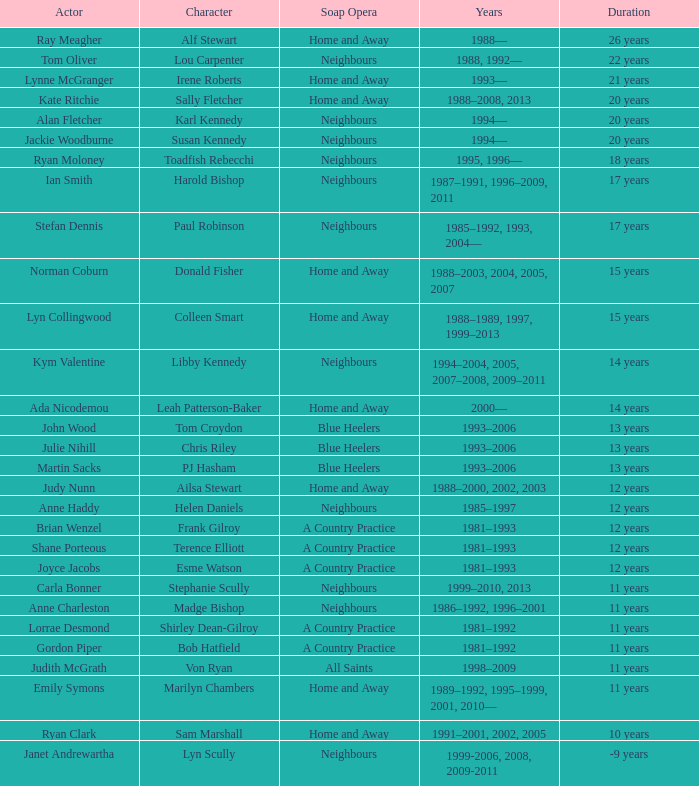Which years did Martin Sacks work on a soap opera? 1993–2006. Could you parse the entire table? {'header': ['Actor', 'Character', 'Soap Opera', 'Years', 'Duration'], 'rows': [['Ray Meagher', 'Alf Stewart', 'Home and Away', '1988—', '26 years'], ['Tom Oliver', 'Lou Carpenter', 'Neighbours', '1988, 1992—', '22 years'], ['Lynne McGranger', 'Irene Roberts', 'Home and Away', '1993—', '21 years'], ['Kate Ritchie', 'Sally Fletcher', 'Home and Away', '1988–2008, 2013', '20 years'], ['Alan Fletcher', 'Karl Kennedy', 'Neighbours', '1994—', '20 years'], ['Jackie Woodburne', 'Susan Kennedy', 'Neighbours', '1994—', '20 years'], ['Ryan Moloney', 'Toadfish Rebecchi', 'Neighbours', '1995, 1996—', '18 years'], ['Ian Smith', 'Harold Bishop', 'Neighbours', '1987–1991, 1996–2009, 2011', '17 years'], ['Stefan Dennis', 'Paul Robinson', 'Neighbours', '1985–1992, 1993, 2004—', '17 years'], ['Norman Coburn', 'Donald Fisher', 'Home and Away', '1988–2003, 2004, 2005, 2007', '15 years'], ['Lyn Collingwood', 'Colleen Smart', 'Home and Away', '1988–1989, 1997, 1999–2013', '15 years'], ['Kym Valentine', 'Libby Kennedy', 'Neighbours', '1994–2004, 2005, 2007–2008, 2009–2011', '14 years'], ['Ada Nicodemou', 'Leah Patterson-Baker', 'Home and Away', '2000—', '14 years'], ['John Wood', 'Tom Croydon', 'Blue Heelers', '1993–2006', '13 years'], ['Julie Nihill', 'Chris Riley', 'Blue Heelers', '1993–2006', '13 years'], ['Martin Sacks', 'PJ Hasham', 'Blue Heelers', '1993–2006', '13 years'], ['Judy Nunn', 'Ailsa Stewart', 'Home and Away', '1988–2000, 2002, 2003', '12 years'], ['Anne Haddy', 'Helen Daniels', 'Neighbours', '1985–1997', '12 years'], ['Brian Wenzel', 'Frank Gilroy', 'A Country Practice', '1981–1993', '12 years'], ['Shane Porteous', 'Terence Elliott', 'A Country Practice', '1981–1993', '12 years'], ['Joyce Jacobs', 'Esme Watson', 'A Country Practice', '1981–1993', '12 years'], ['Carla Bonner', 'Stephanie Scully', 'Neighbours', '1999–2010, 2013', '11 years'], ['Anne Charleston', 'Madge Bishop', 'Neighbours', '1986–1992, 1996–2001', '11 years'], ['Lorrae Desmond', 'Shirley Dean-Gilroy', 'A Country Practice', '1981–1992', '11 years'], ['Gordon Piper', 'Bob Hatfield', 'A Country Practice', '1981–1992', '11 years'], ['Judith McGrath', 'Von Ryan', 'All Saints', '1998–2009', '11 years'], ['Emily Symons', 'Marilyn Chambers', 'Home and Away', '1989–1992, 1995–1999, 2001, 2010—', '11 years'], ['Ryan Clark', 'Sam Marshall', 'Home and Away', '1991–2001, 2002, 2005', '10 years'], ['Janet Andrewartha', 'Lyn Scully', 'Neighbours', '1999-2006, 2008, 2009-2011', '-9 years']]} 